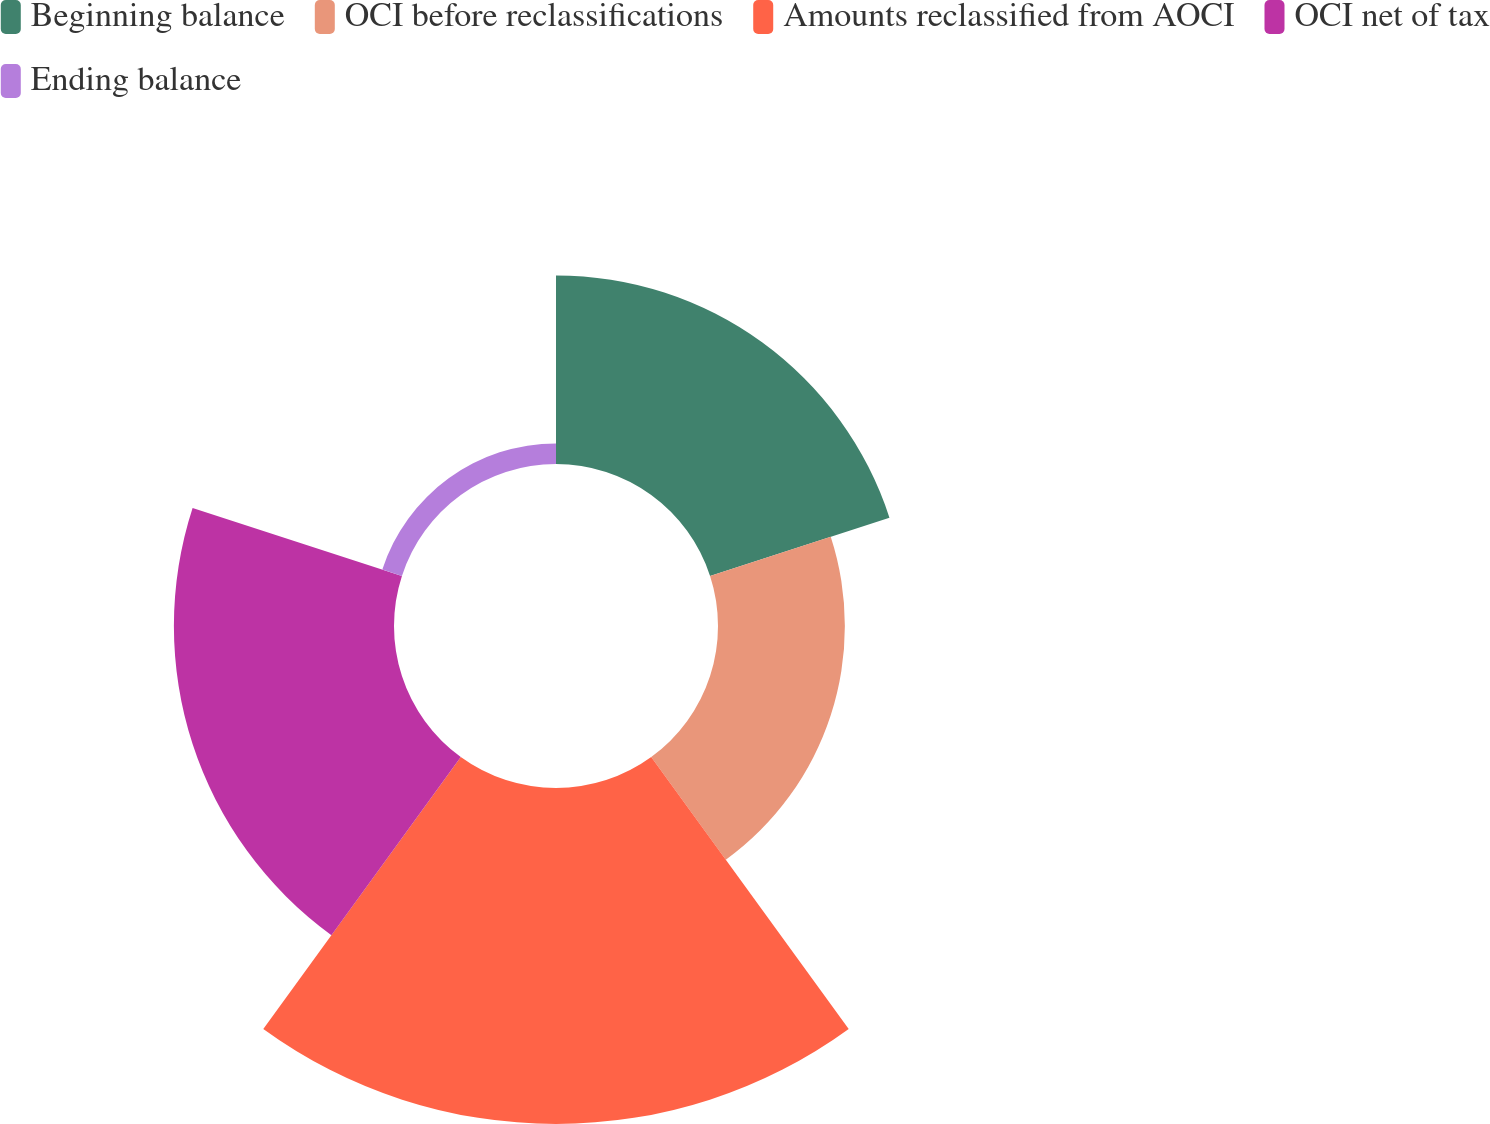Convert chart to OTSL. <chart><loc_0><loc_0><loc_500><loc_500><pie_chart><fcel>Beginning balance<fcel>OCI before reclassifications<fcel>Amounts reclassified from AOCI<fcel>OCI net of tax<fcel>Ending balance<nl><fcel>21.14%<fcel>14.22%<fcel>37.66%<fcel>24.67%<fcel>2.31%<nl></chart> 